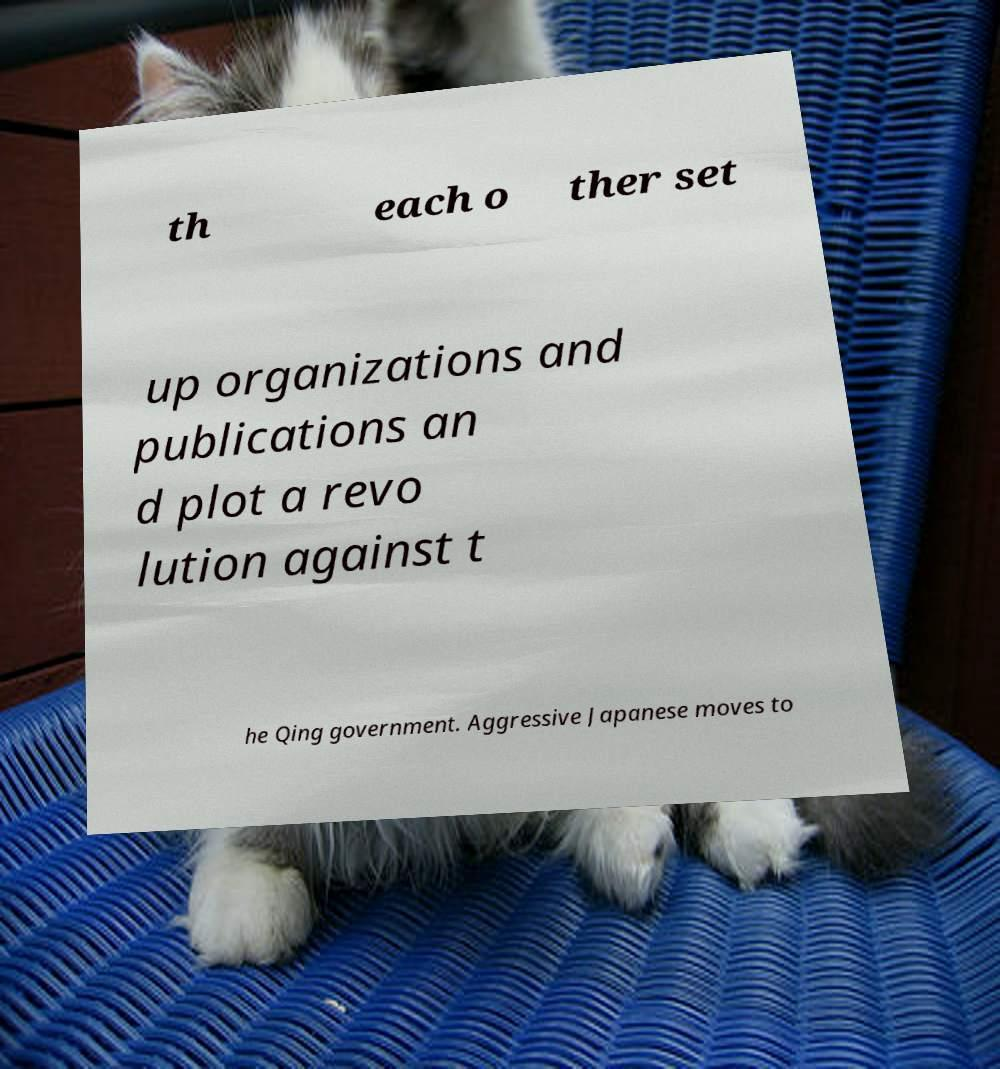Could you assist in decoding the text presented in this image and type it out clearly? th each o ther set up organizations and publications an d plot a revo lution against t he Qing government. Aggressive Japanese moves to 